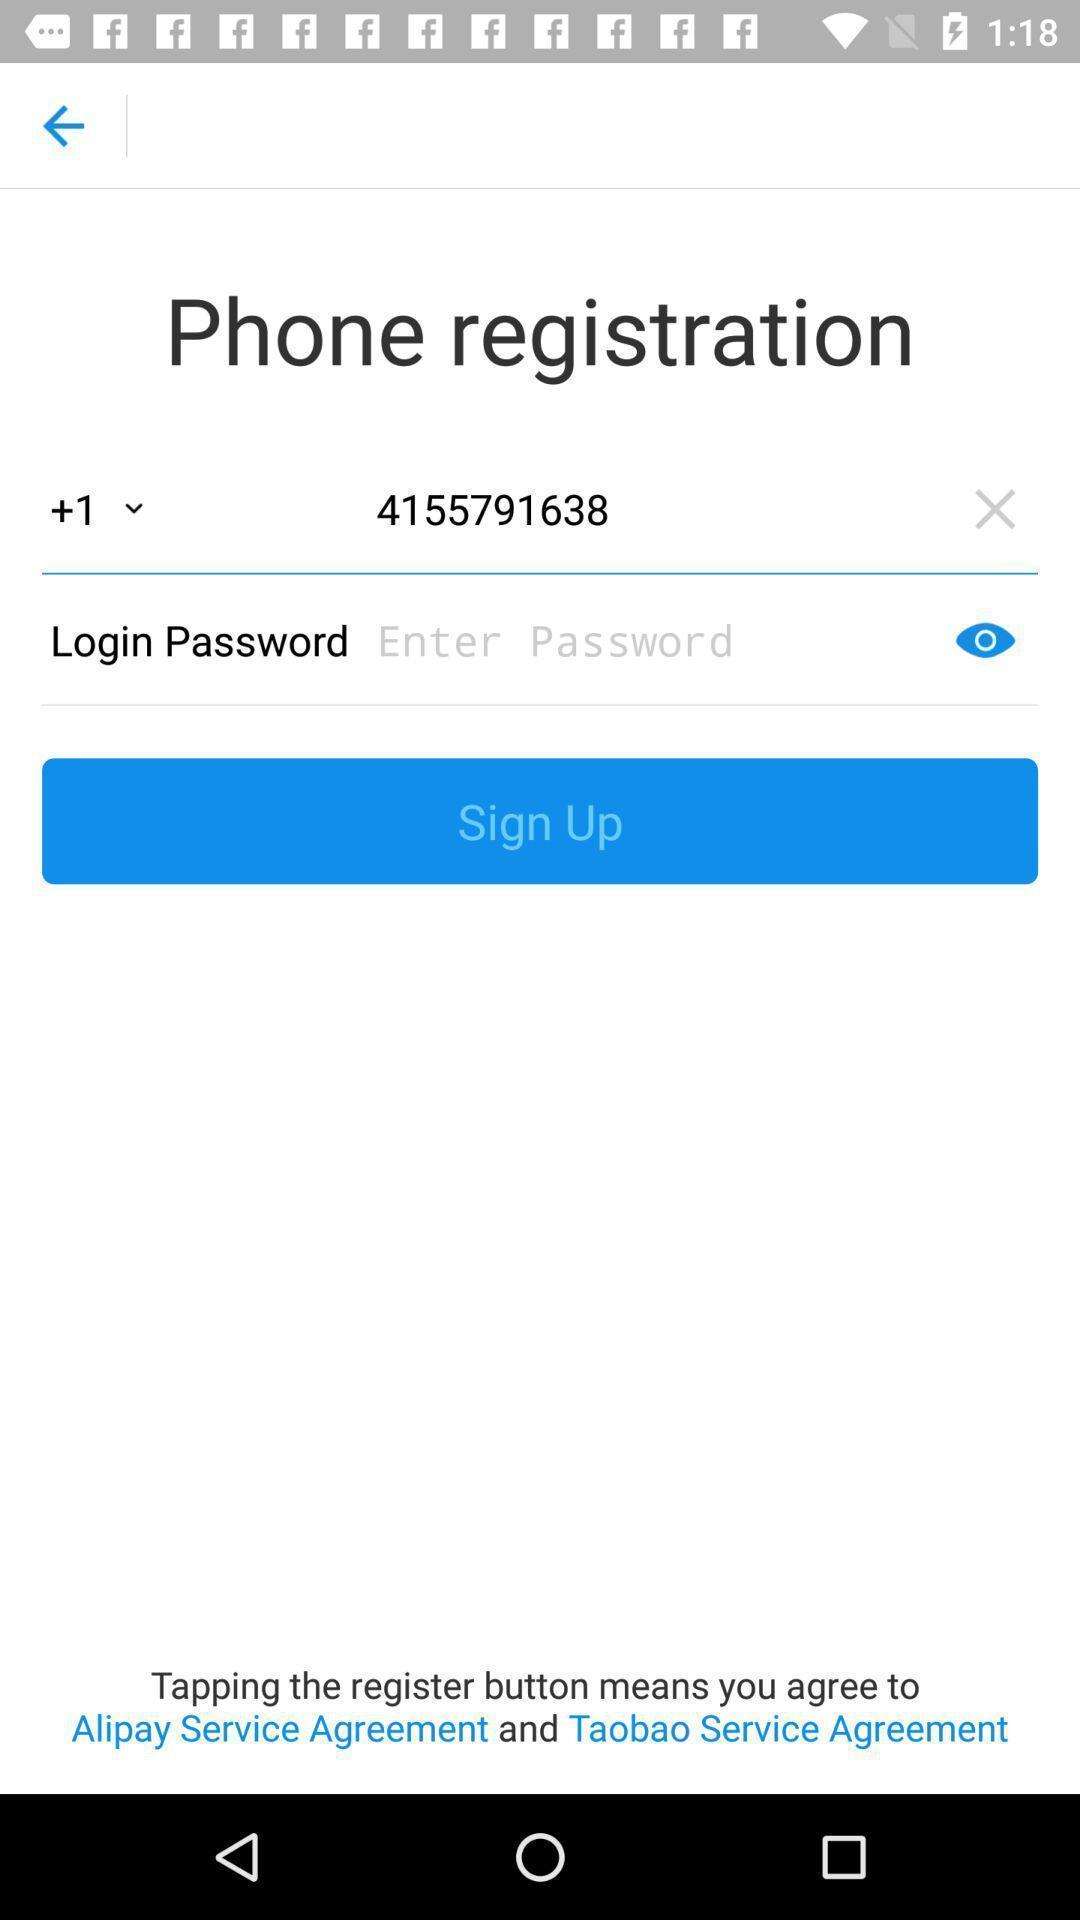Provide a textual representation of this image. Sign up page for phone registration. 